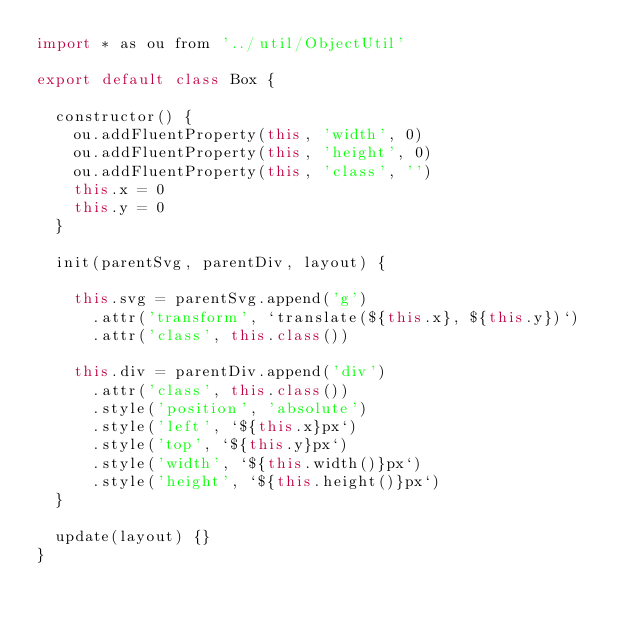<code> <loc_0><loc_0><loc_500><loc_500><_JavaScript_>import * as ou from '../util/ObjectUtil'

export default class Box {

  constructor() {
    ou.addFluentProperty(this, 'width', 0)
    ou.addFluentProperty(this, 'height', 0)
    ou.addFluentProperty(this, 'class', '')
    this.x = 0
    this.y = 0
  }

  init(parentSvg, parentDiv, layout) {

    this.svg = parentSvg.append('g')
      .attr('transform', `translate(${this.x}, ${this.y})`)
      .attr('class', this.class())

    this.div = parentDiv.append('div')
      .attr('class', this.class())
      .style('position', 'absolute')
      .style('left', `${this.x}px`)
      .style('top', `${this.y}px`)
      .style('width', `${this.width()}px`)
      .style('height', `${this.height()}px`)
  }

  update(layout) {}
}
</code> 